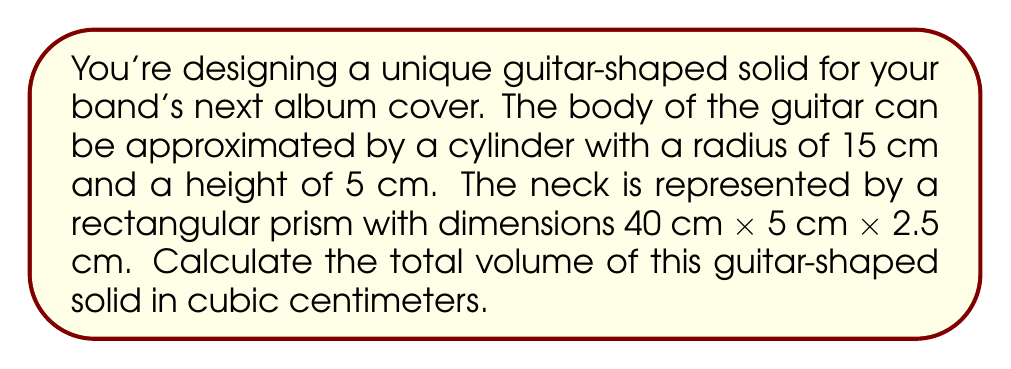Show me your answer to this math problem. To solve this problem, we need to calculate the volumes of the two parts separately and then add them together.

1. Volume of the guitar body (cylinder):
   The formula for the volume of a cylinder is $V = \pi r^2 h$
   where $r$ is the radius and $h$ is the height.

   $$V_{body} = \pi (15\text{ cm})^2 (5\text{ cm})$$
   $$V_{body} = \pi (225\text{ cm}^2) (5\text{ cm})$$
   $$V_{body} = 1125\pi\text{ cm}^3$$

2. Volume of the guitar neck (rectangular prism):
   The formula for the volume of a rectangular prism is $V = l \times w \times h$
   where $l$ is length, $w$ is width, and $h$ is height.

   $$V_{neck} = 40\text{ cm} \times 5\text{ cm} \times 2.5\text{ cm}$$
   $$V_{neck} = 500\text{ cm}^3$$

3. Total volume:
   Add the volumes of the body and neck:

   $$V_{total} = V_{body} + V_{neck}$$
   $$V_{total} = 1125\pi\text{ cm}^3 + 500\text{ cm}^3$$
   $$V_{total} = 1125\pi + 500\text{ cm}^3$$

   Calculating the final result:
   $$V_{total} \approx 4033.19\text{ cm}^3$$
Answer: The total volume of the guitar-shaped solid is approximately 4033.19 cubic centimeters. 